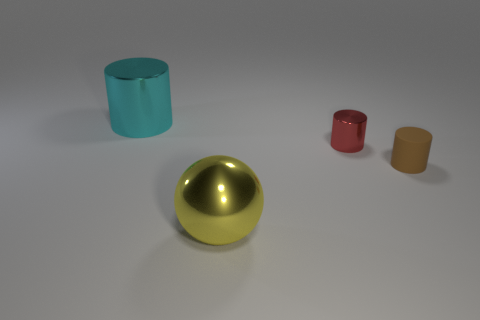What shape is the large cyan thing?
Your answer should be compact. Cylinder. What number of green things are small cylinders or metal things?
Give a very brief answer. 0. What number of other objects are the same material as the small brown cylinder?
Your answer should be very brief. 0. There is a large metal thing left of the yellow metal ball; is its shape the same as the small metal object?
Offer a very short reply. Yes. Are any tiny rubber cylinders visible?
Offer a very short reply. Yes. Are there any other things that have the same shape as the large yellow shiny thing?
Your response must be concise. No. Are there more cylinders right of the red shiny cylinder than purple balls?
Your response must be concise. Yes. Are there any metallic objects in front of the rubber cylinder?
Provide a succinct answer. Yes. Is the size of the yellow shiny sphere the same as the cyan cylinder?
Make the answer very short. Yes. There is another metallic object that is the same shape as the cyan metal thing; what is its size?
Give a very brief answer. Small. 